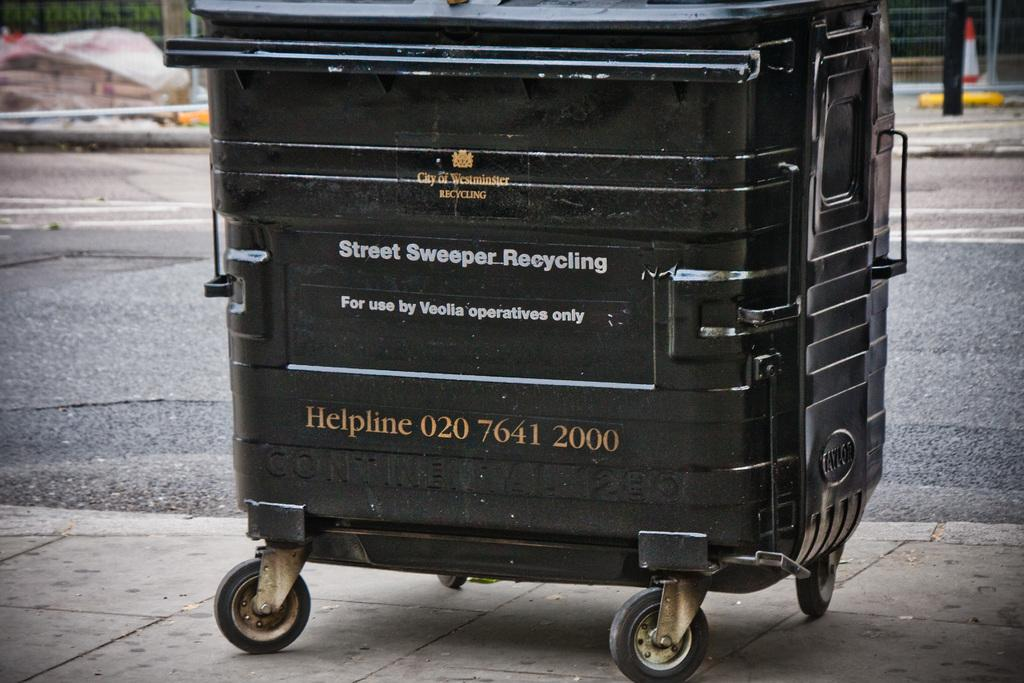What is the main object in the center of the image? There is a black color dustbin in the center of the image. What can be seen at the bottom of the image? There is a road visible at the bottom of the image. Where is the lunchroom located in the image? There is no lunchroom present in the image. Is there a river flowing near the dustbin in the image? There is no river visible in the image. 